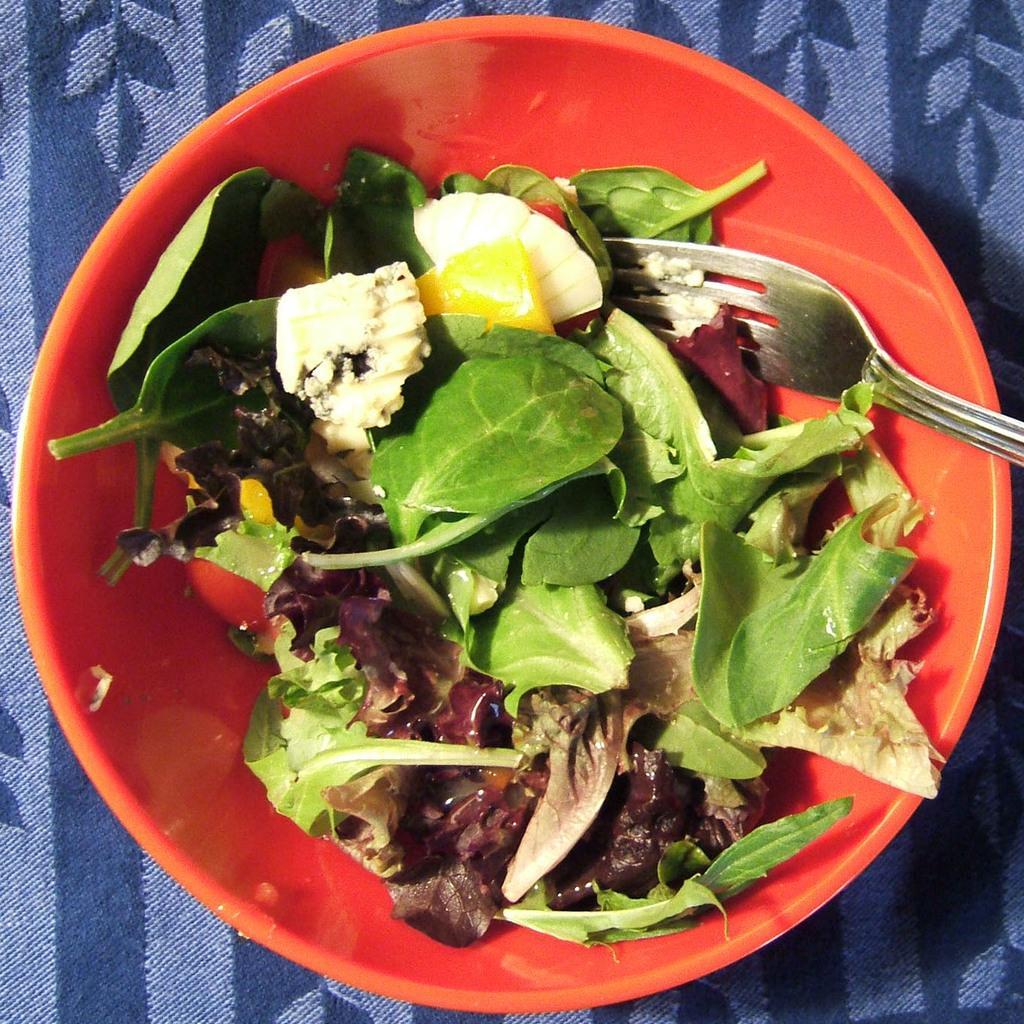Can you describe this image briefly? In this image, we can see food and a fork in the bowl and in the background, there is a cloth on the table. 